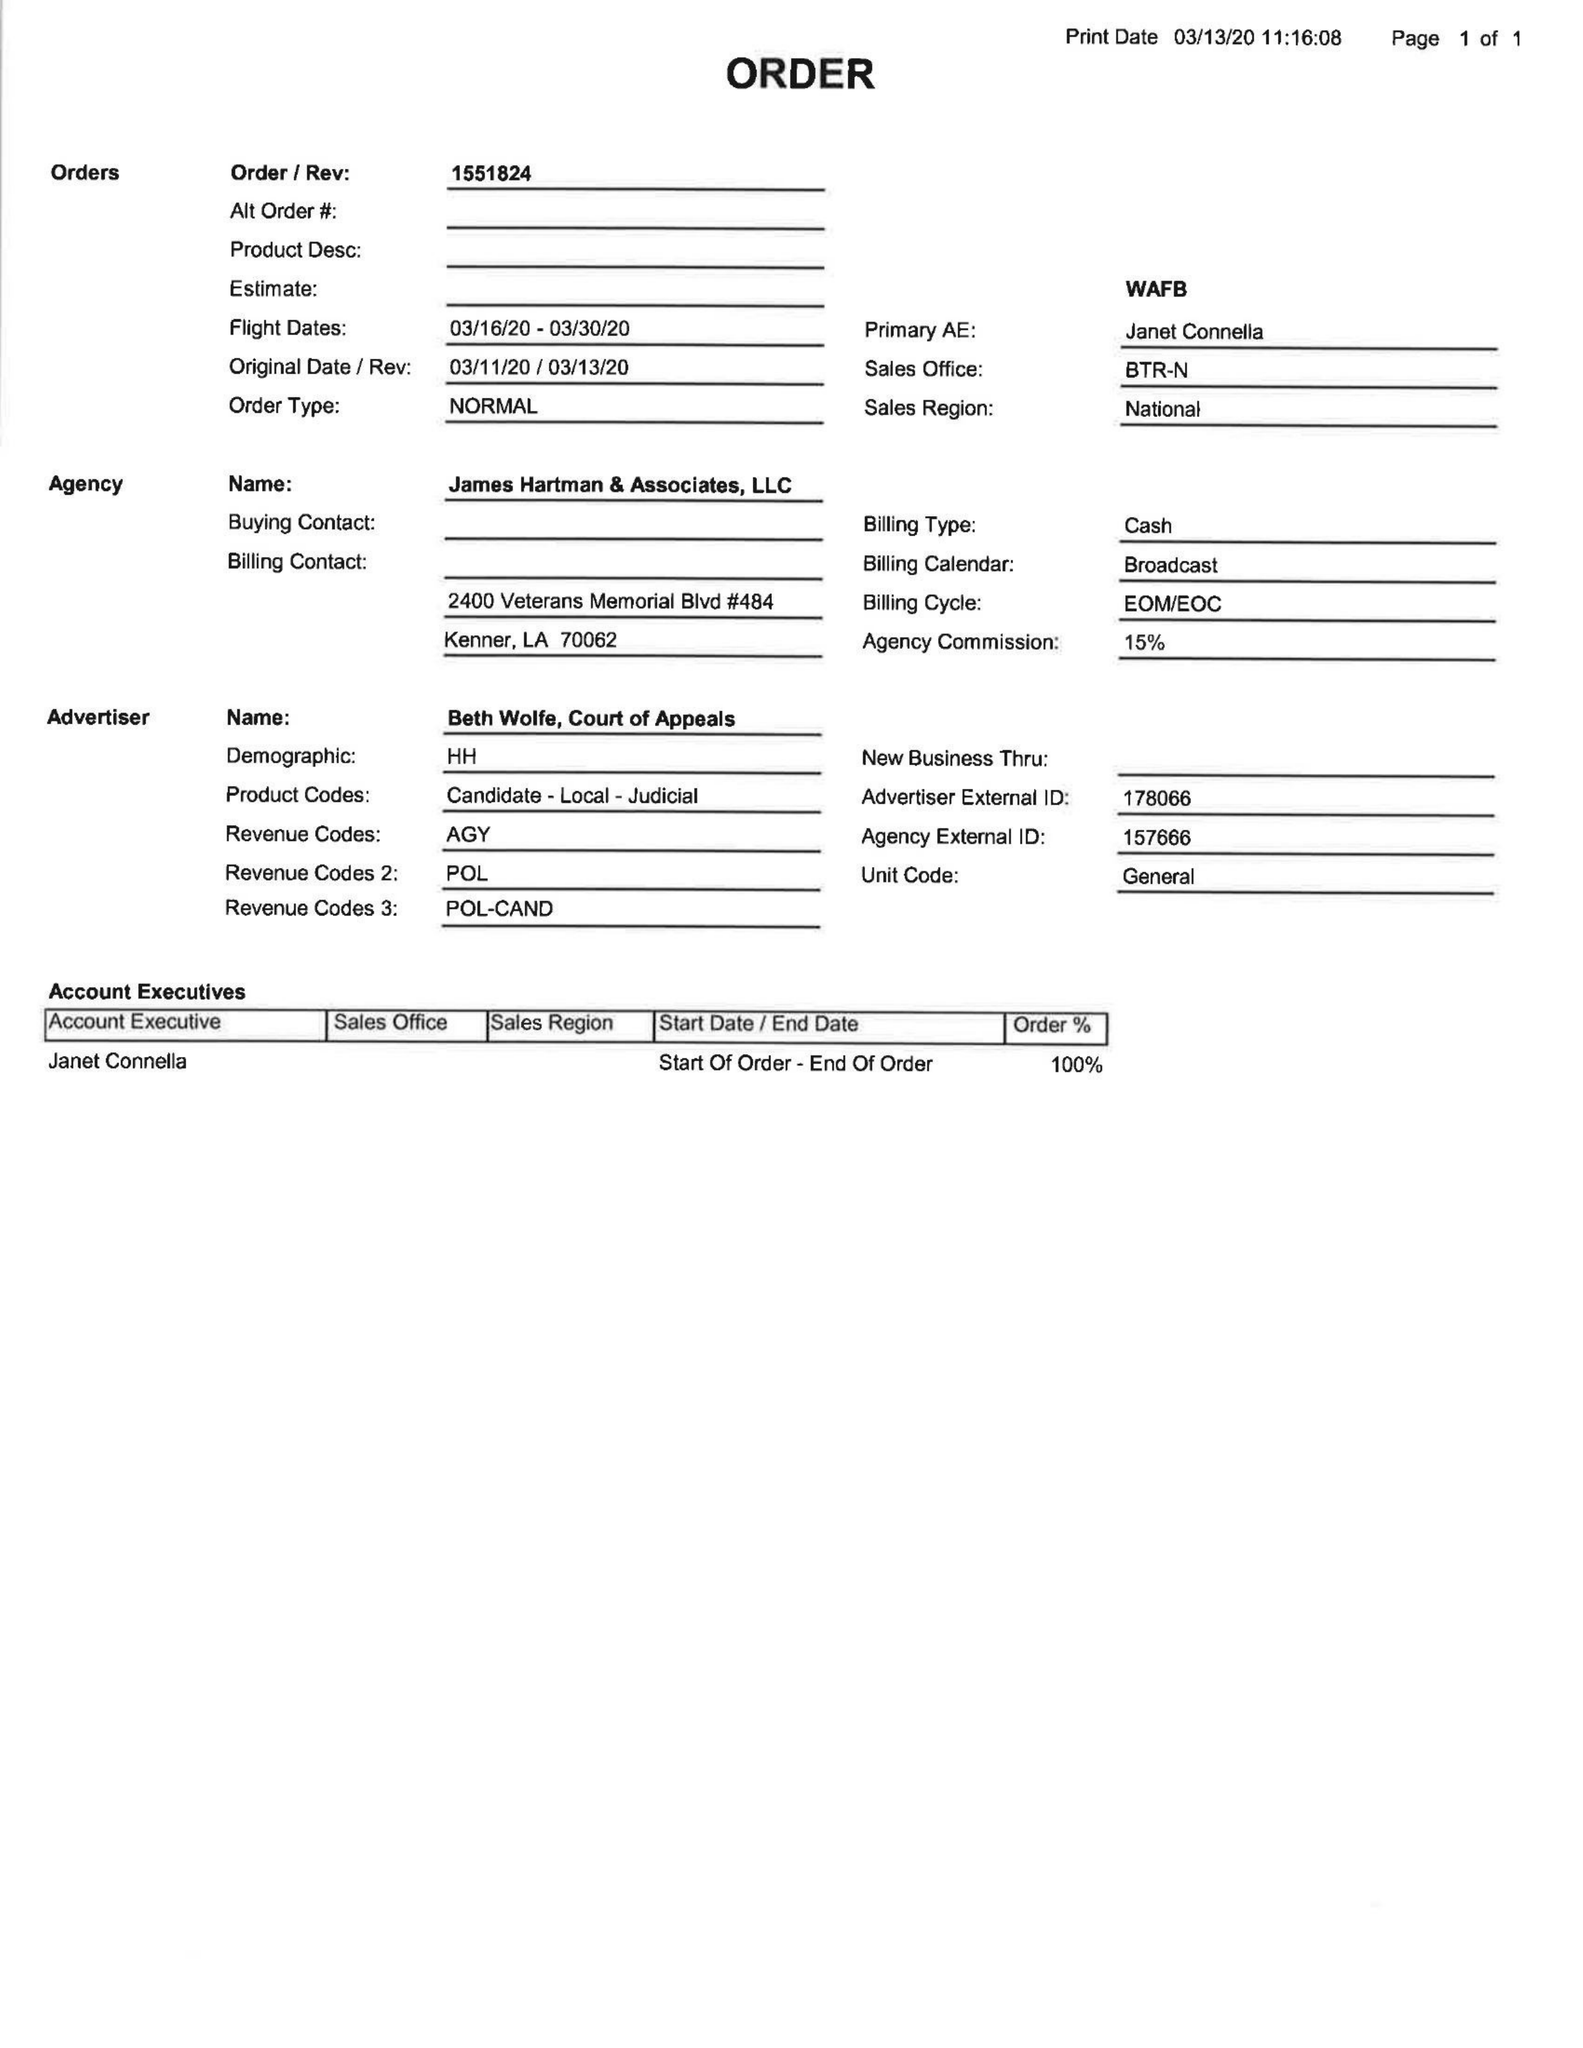What is the value for the flight_to?
Answer the question using a single word or phrase. 03/30/20 